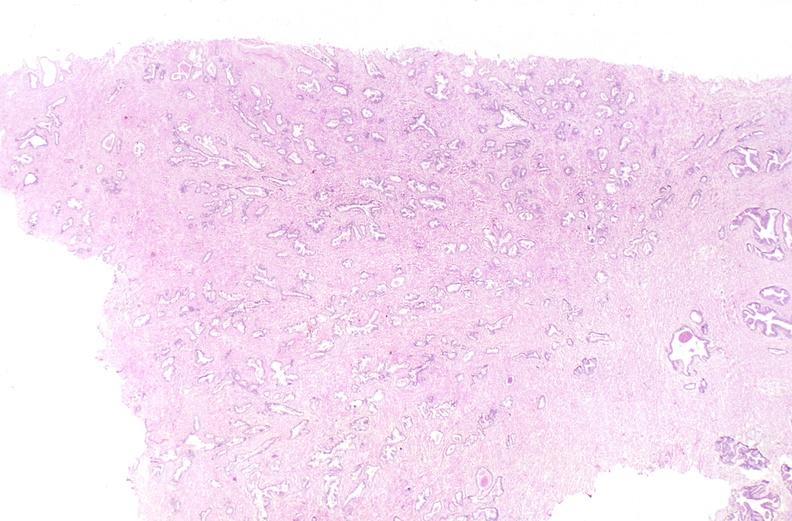what does this image show?
Answer the question using a single word or phrase. Prostate 